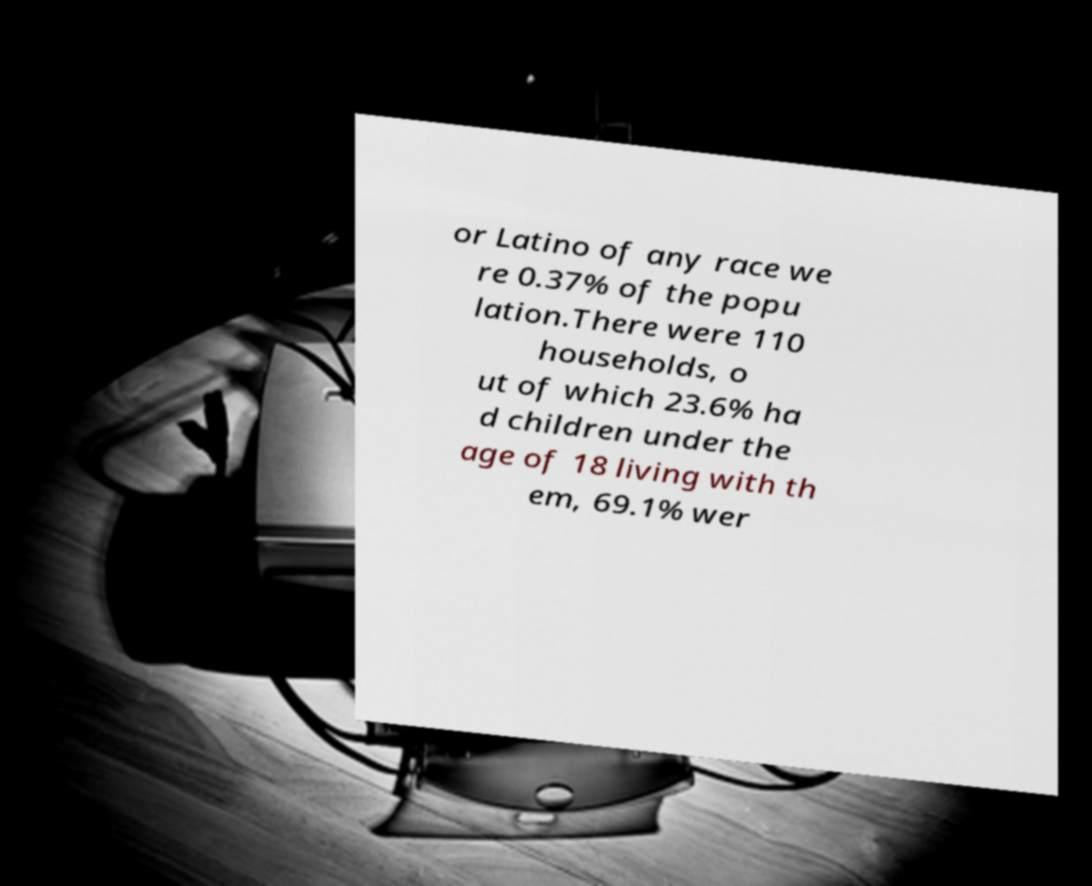Can you accurately transcribe the text from the provided image for me? or Latino of any race we re 0.37% of the popu lation.There were 110 households, o ut of which 23.6% ha d children under the age of 18 living with th em, 69.1% wer 